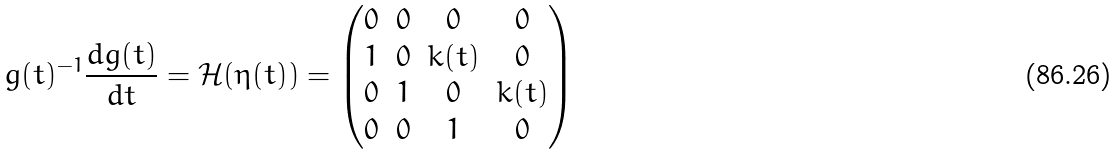Convert formula to latex. <formula><loc_0><loc_0><loc_500><loc_500>g ( t ) ^ { - 1 } \frac { d g ( t ) } { d t } = \mathcal { H } ( \eta ( t ) ) = \begin{pmatrix} 0 & 0 & 0 & 0 \\ 1 & 0 & k ( t ) & 0 \\ 0 & 1 & 0 & k ( t ) \\ 0 & 0 & 1 & 0 \end{pmatrix}</formula> 